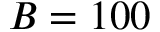Convert formula to latex. <formula><loc_0><loc_0><loc_500><loc_500>B = 1 0 0</formula> 